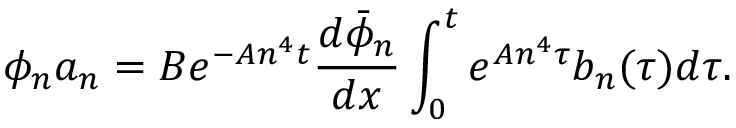Convert formula to latex. <formula><loc_0><loc_0><loc_500><loc_500>\phi _ { n } a _ { n } = B e ^ { - A n ^ { 4 } t } \frac { d \bar { \phi } _ { n } } { d x } \int _ { 0 } ^ { t } e ^ { A n ^ { 4 } \tau } b _ { n } ( \tau ) d \tau .</formula> 